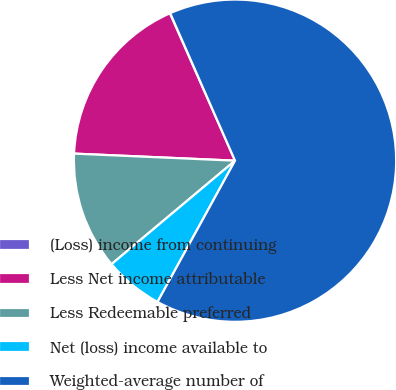Convert chart. <chart><loc_0><loc_0><loc_500><loc_500><pie_chart><fcel>(Loss) income from continuing<fcel>Less Net income attributable<fcel>Less Redeemable preferred<fcel>Net (loss) income available to<fcel>Weighted-average number of<nl><fcel>0.03%<fcel>17.68%<fcel>11.8%<fcel>5.91%<fcel>64.58%<nl></chart> 